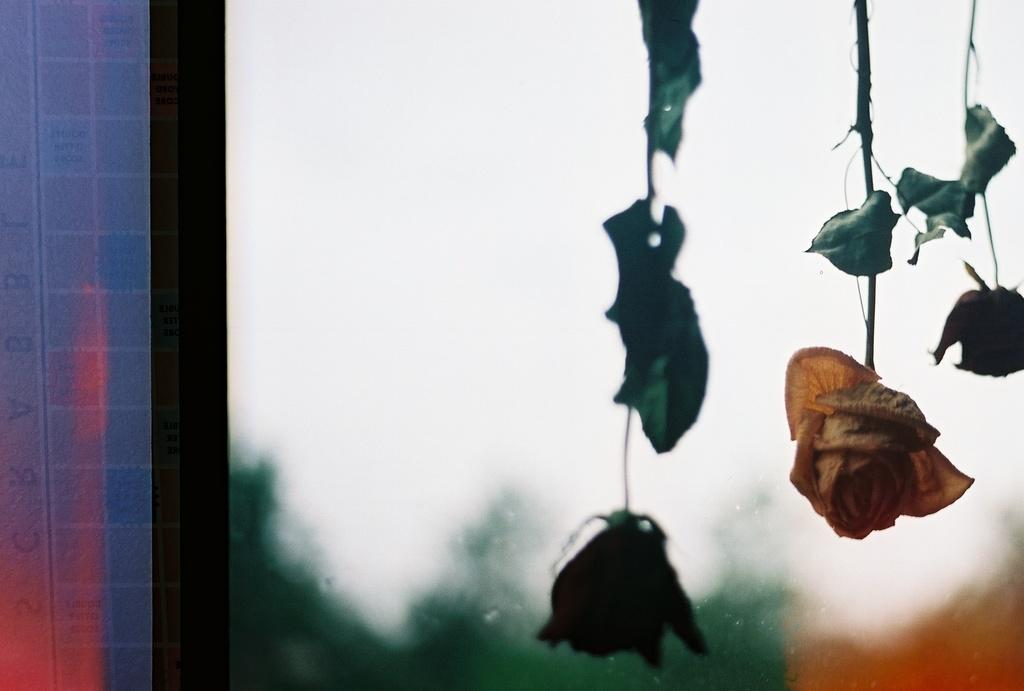How many flowers are visible in the image? There are three flowers in the image. What is the position of the flowers in the image? The flowers are hanging in the image. Where are the flowers located in relation to other objects in the image? The flowers are in front of a window. What type of music can be heard coming from the flowers in the image? There is no music coming from the flowers in the image, as flowers do not produce sound. 